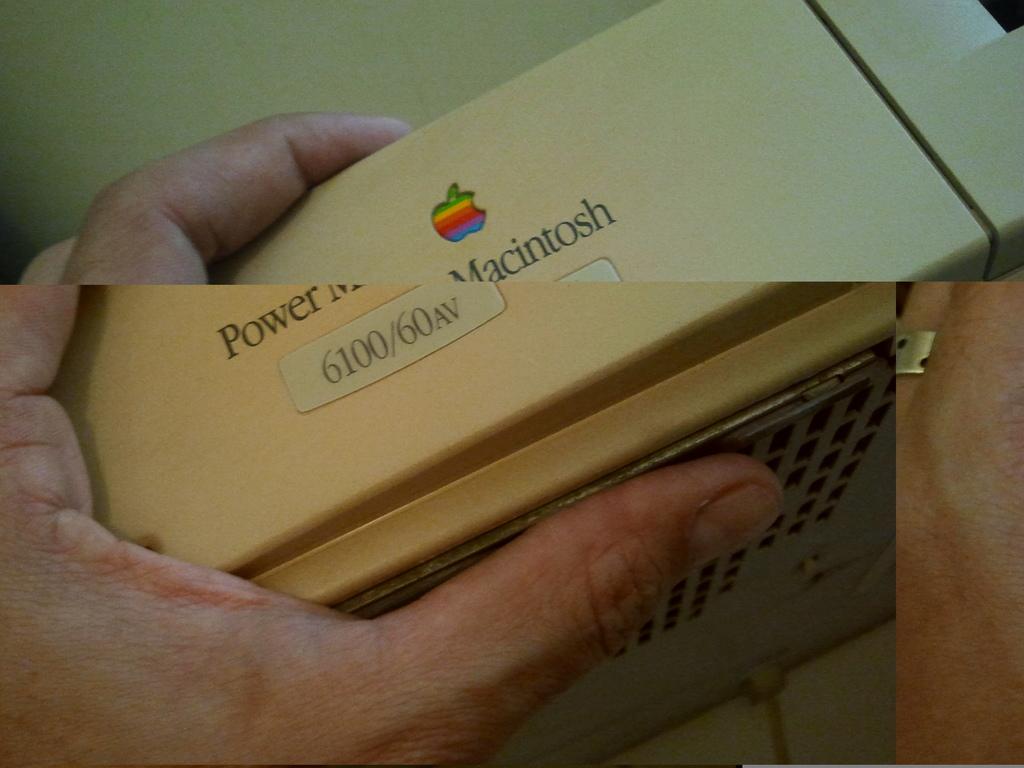What brand is this device?
Ensure brevity in your answer.  Macintosh. What are the letters after 6100/60?
Provide a short and direct response. Av. 